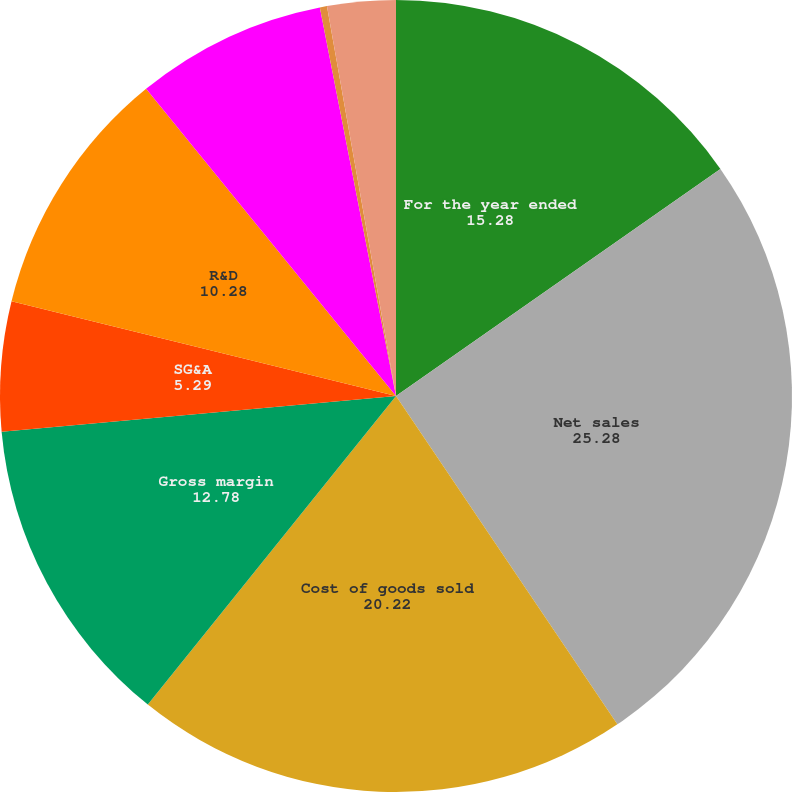Convert chart to OTSL. <chart><loc_0><loc_0><loc_500><loc_500><pie_chart><fcel>For the year ended<fcel>Net sales<fcel>Cost of goods sold<fcel>Gross margin<fcel>SG&A<fcel>R&D<fcel>Operating income (loss)<fcel>Interest income (expense) net<fcel>Net income (loss) attributable<nl><fcel>15.28%<fcel>25.28%<fcel>20.22%<fcel>12.78%<fcel>5.29%<fcel>10.28%<fcel>7.79%<fcel>0.29%<fcel>2.79%<nl></chart> 